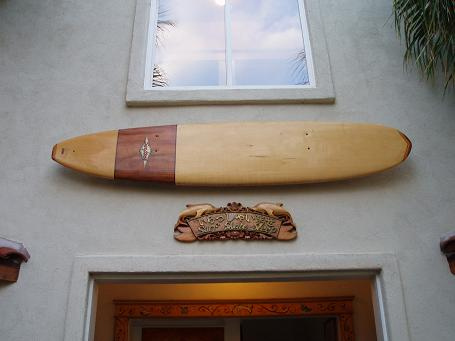<image>What does it say under the board? It is unclear what it says under the board, the image does not provide a clear view. What does it say under the board? I don't know what it says under the board. It can be seen as 'surf state', 'fancy design', 'unclear', 'faithful', 'surf something or other', 'surf suite place', or 'nothing'. 